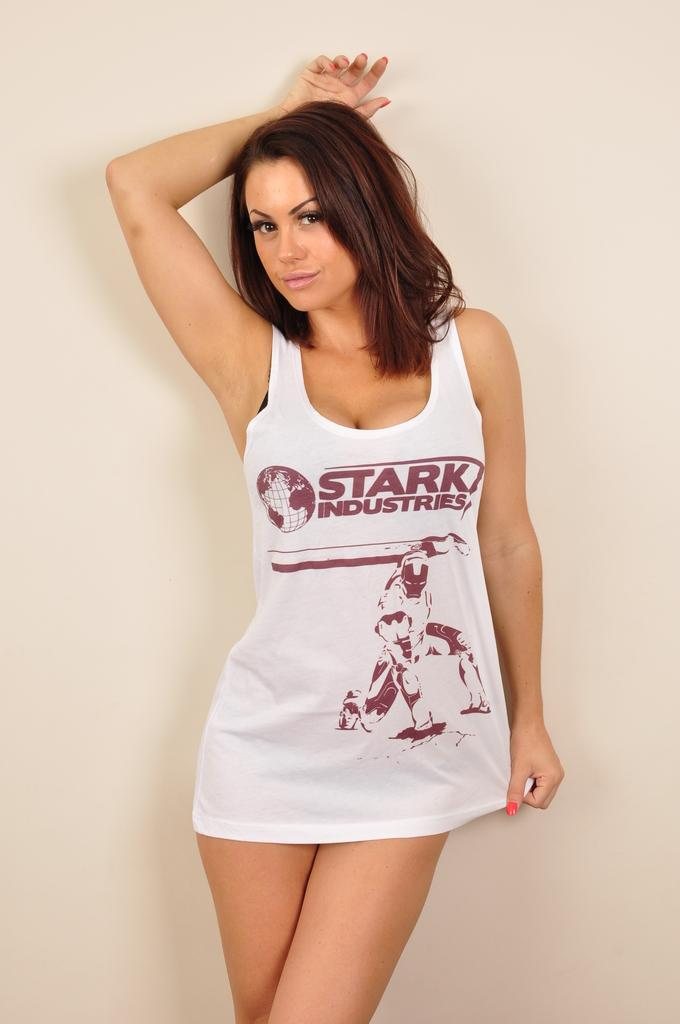Provide a one-sentence caption for the provided image. A brown haired woman wearing a "Stark Industries" shirt. 